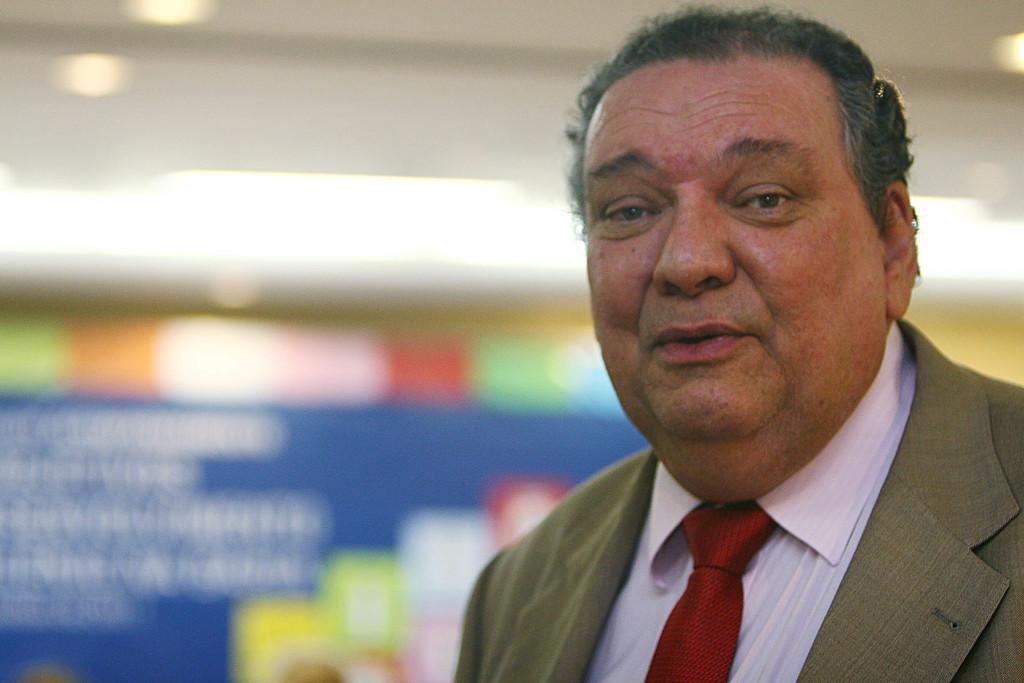In one or two sentences, can you explain what this image depicts? In this image I can see a person wearing brown blazer, white shirt and red color tie and I can see blurred background. 